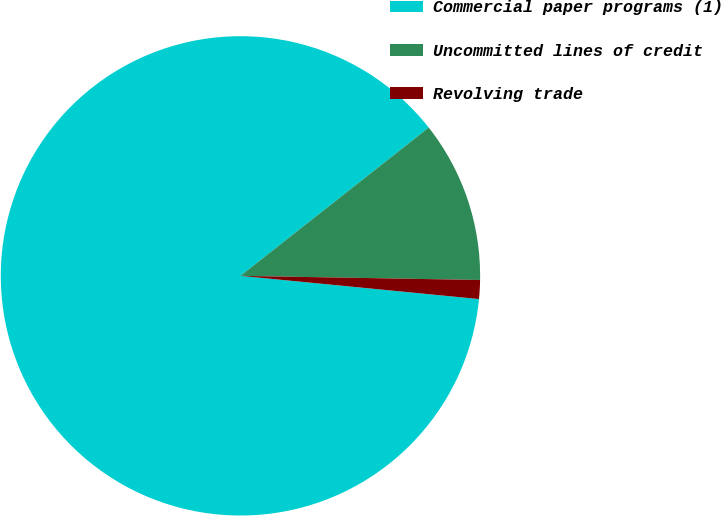Convert chart to OTSL. <chart><loc_0><loc_0><loc_500><loc_500><pie_chart><fcel>Commercial paper programs (1)<fcel>Uncommitted lines of credit<fcel>Revolving trade<nl><fcel>87.84%<fcel>10.89%<fcel>1.27%<nl></chart> 